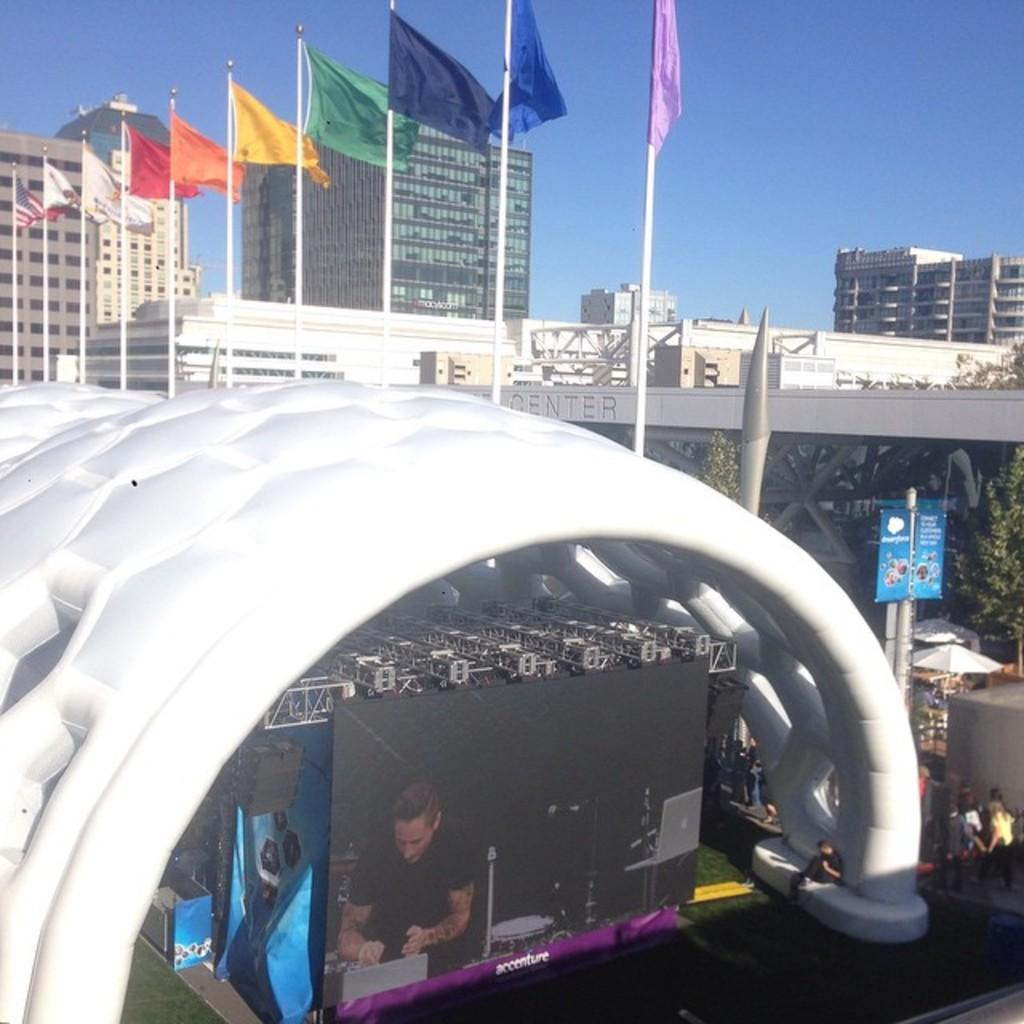What type of structures can be seen in the image? There are buildings in the image. What is attached to the flag posts? Flags are present on flag posts. What type of vegetation is visible in the image? There are trees in the image. What might provide information to people in the image? Information boards are visible. What might provide shade for people in the image? Parasols are present. What are the people in the image doing? Persons are standing on the road. What might display information or advertisements in the image? A display screen is visible. What type of protective barriers are present in the image? Iron grills are present. What can be seen in the sky in the image? The sky is visible in the image. How does the pail help maintain balance in the image? There is no pail present in the image, so it cannot help maintain balance. What type of health-related equipment is visible in the image? There is no health-related equipment visible in the image. 